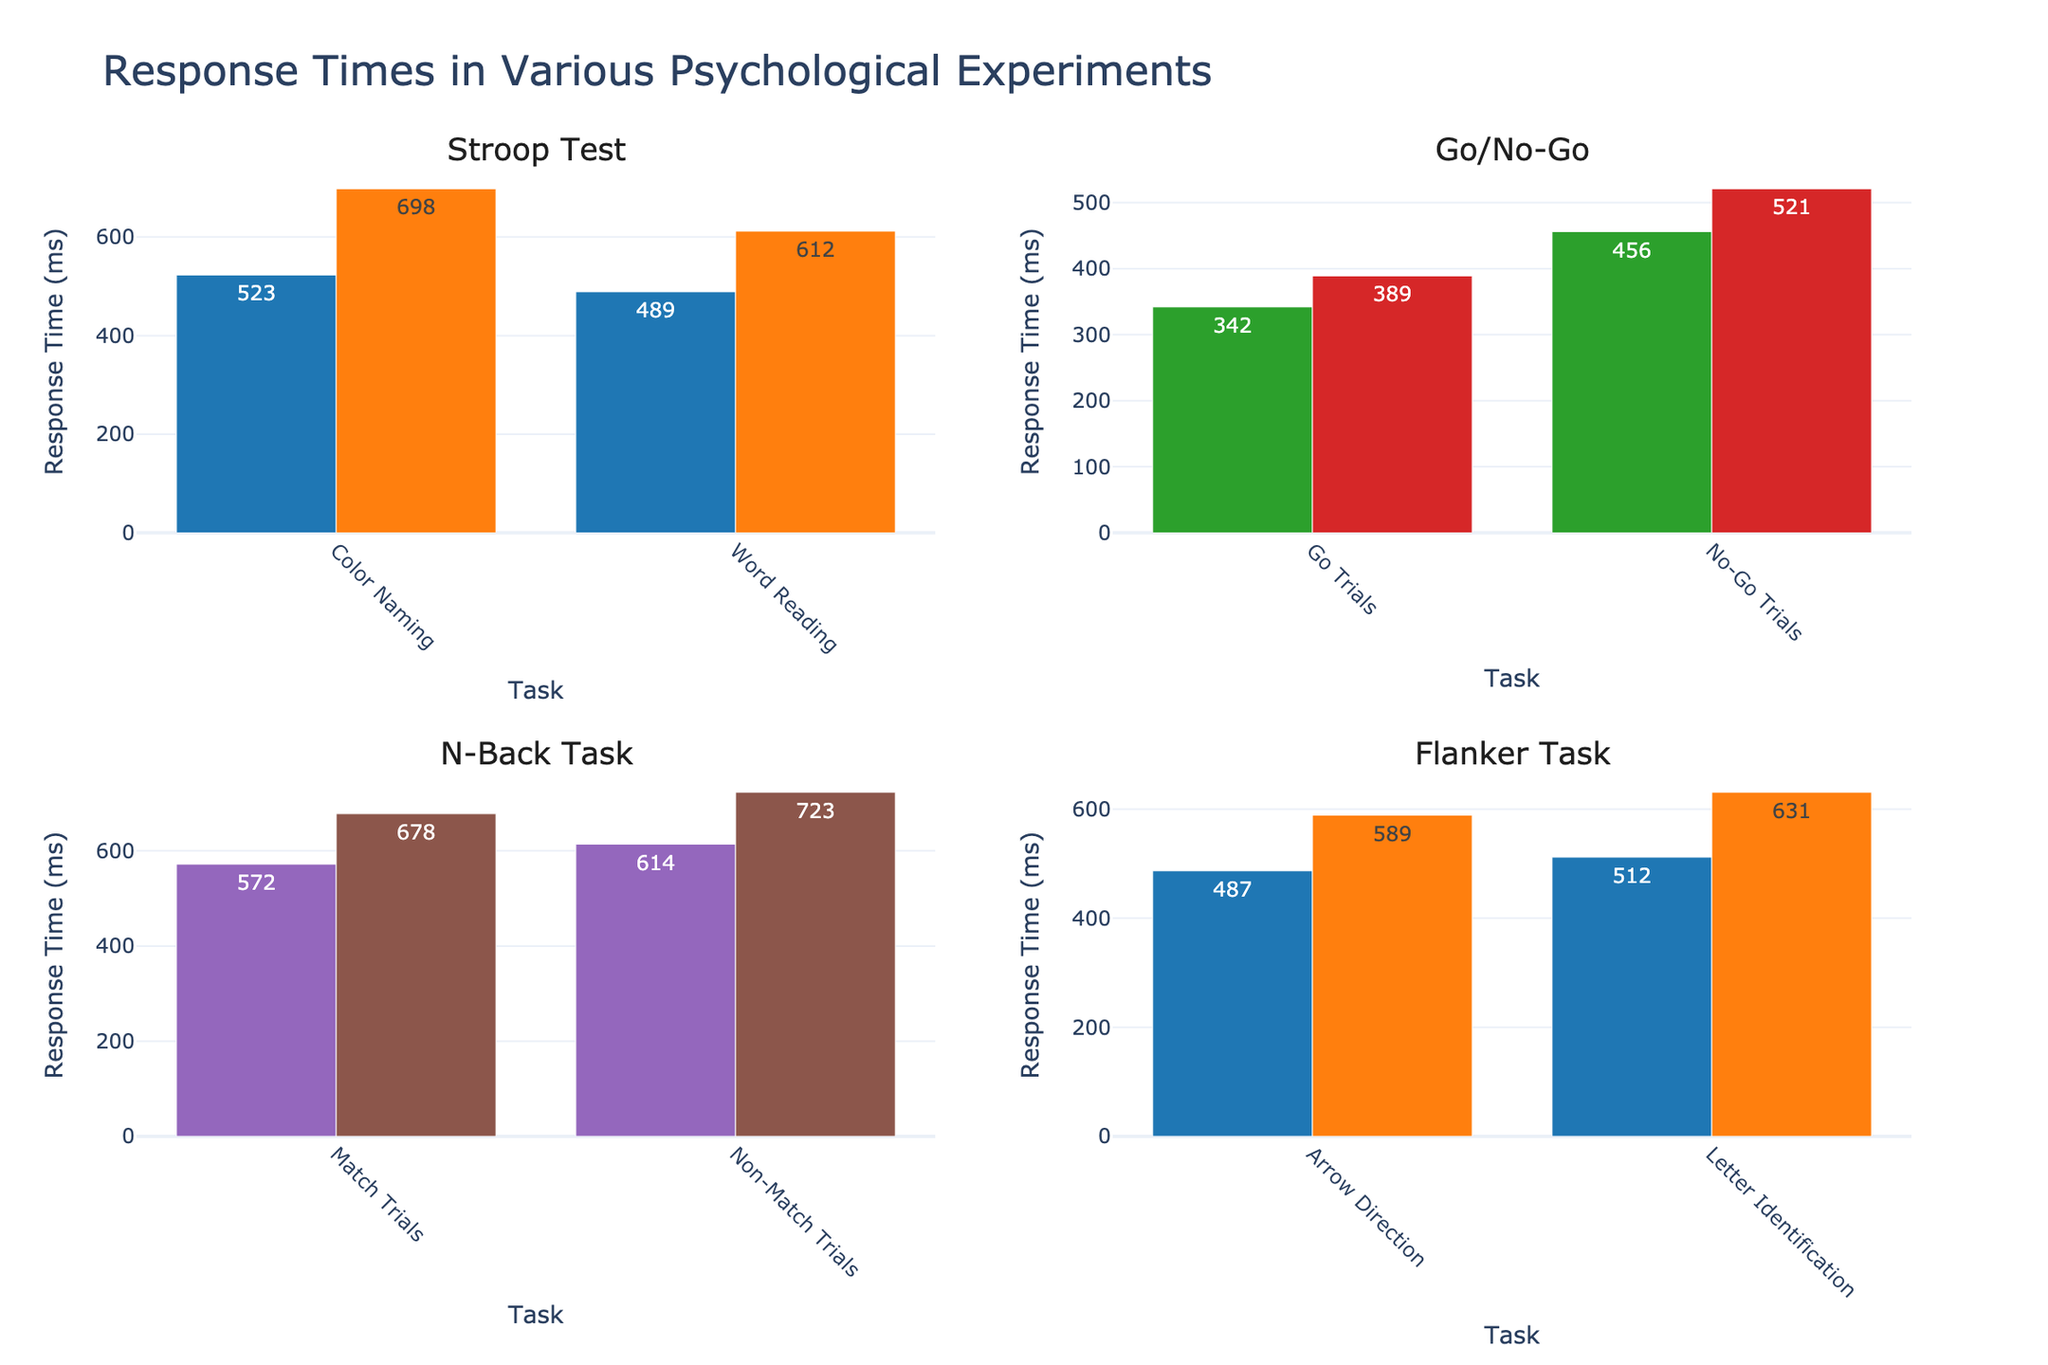What's the title of the figure? The title is located at the top center of the figure. It provides a summary of the content displayed in the figure.
Answer: Response Times in Various Psychological Experiments How many experiments are displayed in the figure? The figure has four subplots, each representing a different experiment as indicated by the subplot titles.
Answer: Four Which task has the fastest response time in the Go/No-Go experiment? In the Go/No-Go subplot, compare the bar heights. The 'Go Trials' under 'Low Cognitive Load' has the lowest bar, representing the fastest response time.
Answer: Go Trials under Low Cognitive Load What's the difference in response times between the 'Congruent' and 'Incongruent' conditions in the Flanker Task for Arrow Direction? Subtract the response time of 'Congruent' from 'Incongruent' for the Arrow Direction task in the Flanker Task subplot. This is 589 - 487.
Answer: 102 ms Which experiment shows the largest increase in response time between two conditions? Examine the increase in bar heights within each experiment. The Stroop Test shows the largest increase from 'Congruent' to 'Incongruent' for Color Naming (698 - 523) and Word Reading (612 - 489).
Answer: Stroop Test Are there any tasks where the response times in 'Low Cognitive Load' are higher than in 'High Cognitive Load' in the Go/No-Go experiment? Compare the heights of 'Low Cognitive Load' vs. 'High Cognitive Load' bars for each task in the Go/No-Go subplot. All 'Low Cognitive Load' bars are lower.
Answer: No Which has a higher response time in the 2-Back condition, Match Trials or Non-Match Trials? In the N-Back Task subplot under the '2-Back' condition, compare the bar heights of Match Trials and Non-Match Trials. The Non-Match Trials bar is higher.
Answer: Non-Match Trials What is the average response time for the 'Congruent' condition across all experiments? Add the response times for all tasks in the 'Congruent' condition across each experiment and divide by the number of these tasks. (523+489+487+512) / 4 = 502.75 ms
Answer: 502.75 ms How do response times compare between '1-Back' and '2-Back' in the N-Back Task? Compare the total heights of the corresponding bars for both '1-Back' and '2-Back' conditions. '2-Back' has generally higher response times.
Answer: '2-Back' is higher What is the range of response times in the Stroop Test under the Incongruent condition? Subtract the minimum response time from the maximum response time within the Incongruent condition of the Stroop Test. This is 698 - 612.
Answer: 86 ms Which condition has the shortest response time across all experiments? Identify the shortest bar in all subplots. In the Go/No-Go experiment, 'Go Trials' under 'Low Cognitive Load' is the shortest.
Answer: Low Cognitive Load - Go Trials in Go/No-Go 